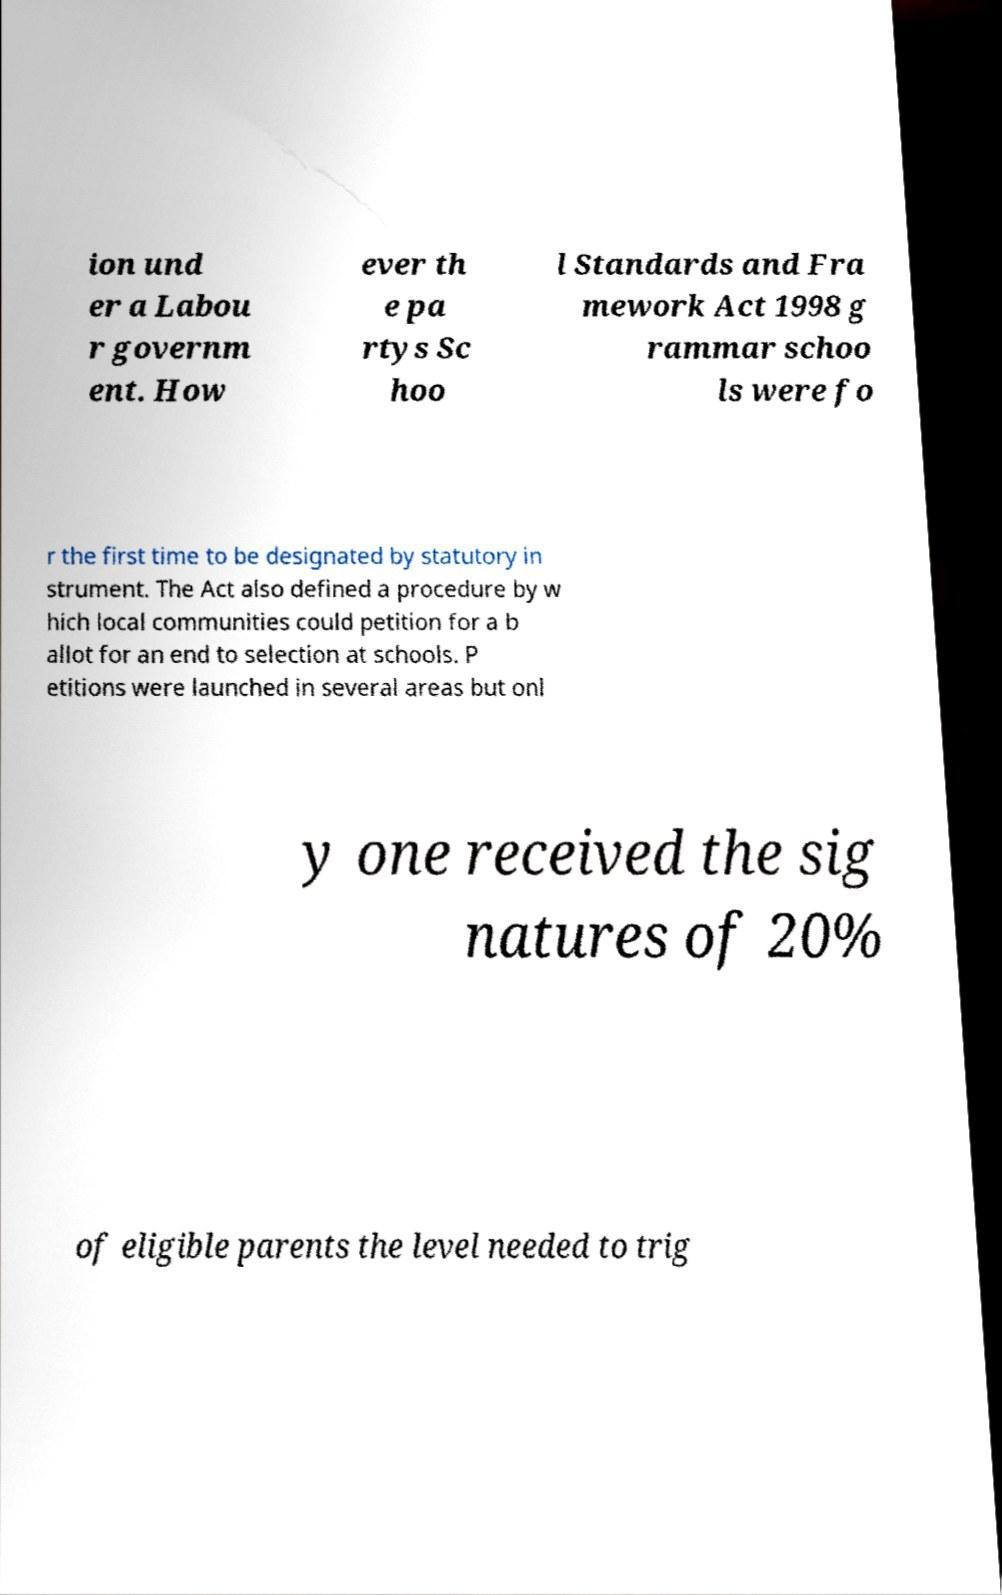Can you accurately transcribe the text from the provided image for me? ion und er a Labou r governm ent. How ever th e pa rtys Sc hoo l Standards and Fra mework Act 1998 g rammar schoo ls were fo r the first time to be designated by statutory in strument. The Act also defined a procedure by w hich local communities could petition for a b allot for an end to selection at schools. P etitions were launched in several areas but onl y one received the sig natures of 20% of eligible parents the level needed to trig 